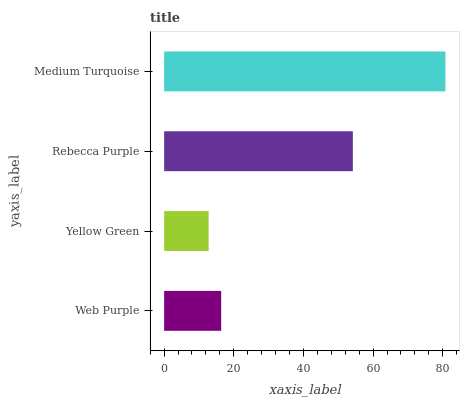Is Yellow Green the minimum?
Answer yes or no. Yes. Is Medium Turquoise the maximum?
Answer yes or no. Yes. Is Rebecca Purple the minimum?
Answer yes or no. No. Is Rebecca Purple the maximum?
Answer yes or no. No. Is Rebecca Purple greater than Yellow Green?
Answer yes or no. Yes. Is Yellow Green less than Rebecca Purple?
Answer yes or no. Yes. Is Yellow Green greater than Rebecca Purple?
Answer yes or no. No. Is Rebecca Purple less than Yellow Green?
Answer yes or no. No. Is Rebecca Purple the high median?
Answer yes or no. Yes. Is Web Purple the low median?
Answer yes or no. Yes. Is Yellow Green the high median?
Answer yes or no. No. Is Medium Turquoise the low median?
Answer yes or no. No. 